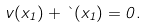Convert formula to latex. <formula><loc_0><loc_0><loc_500><loc_500>v ( x _ { 1 } ) + \theta ( x _ { 1 } ) = 0 .</formula> 